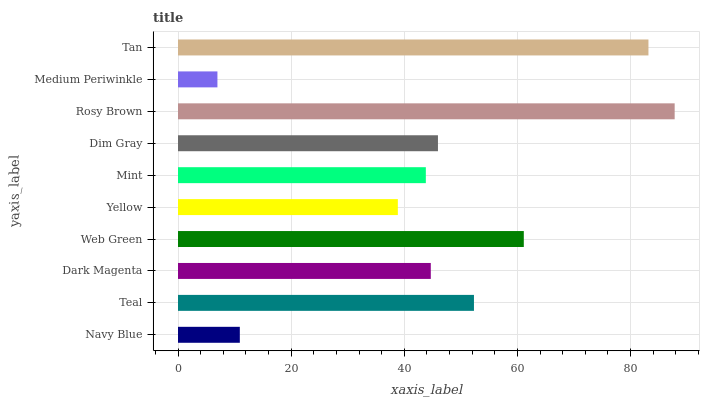Is Medium Periwinkle the minimum?
Answer yes or no. Yes. Is Rosy Brown the maximum?
Answer yes or no. Yes. Is Teal the minimum?
Answer yes or no. No. Is Teal the maximum?
Answer yes or no. No. Is Teal greater than Navy Blue?
Answer yes or no. Yes. Is Navy Blue less than Teal?
Answer yes or no. Yes. Is Navy Blue greater than Teal?
Answer yes or no. No. Is Teal less than Navy Blue?
Answer yes or no. No. Is Dim Gray the high median?
Answer yes or no. Yes. Is Dark Magenta the low median?
Answer yes or no. Yes. Is Web Green the high median?
Answer yes or no. No. Is Tan the low median?
Answer yes or no. No. 